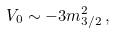Convert formula to latex. <formula><loc_0><loc_0><loc_500><loc_500>V _ { 0 } \sim - 3 m _ { 3 / 2 } ^ { 2 } \, ,</formula> 